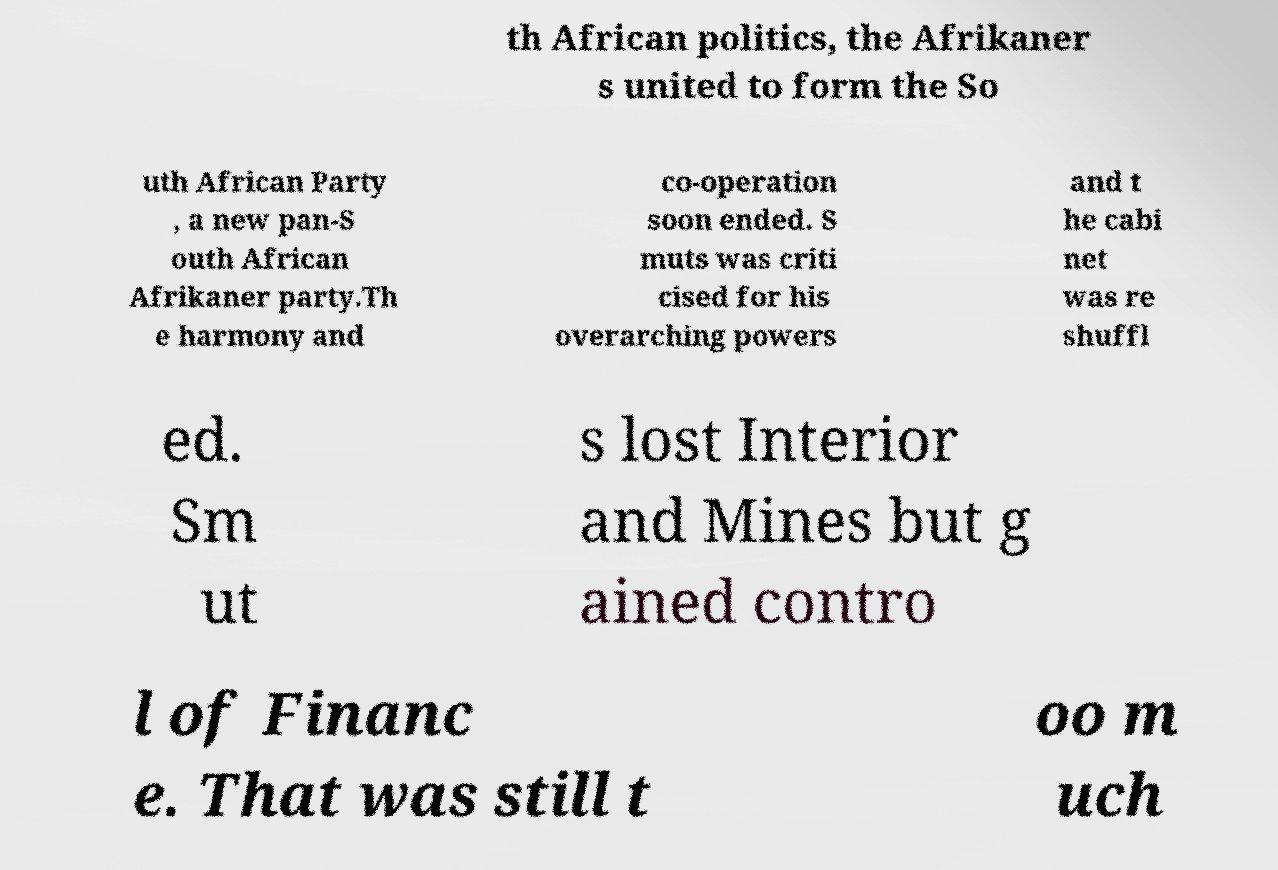Please identify and transcribe the text found in this image. th African politics, the Afrikaner s united to form the So uth African Party , a new pan-S outh African Afrikaner party.Th e harmony and co-operation soon ended. S muts was criti cised for his overarching powers and t he cabi net was re shuffl ed. Sm ut s lost Interior and Mines but g ained contro l of Financ e. That was still t oo m uch 